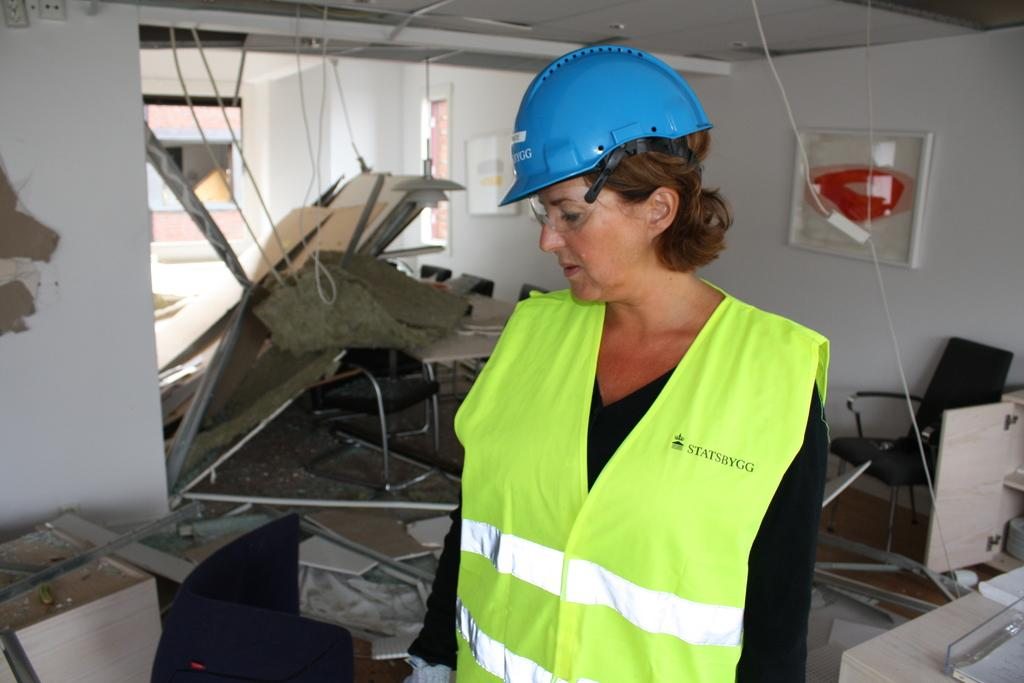Who is the main subject in the image? There is a lady in the center of the image. What is the lady wearing on her head? The lady is wearing a helmet. What can be seen in the background of the image? There are chairs and wooden materials in the background of the image. Where is the table located in the image? There is a table in the right corner of the image. Can you tell me how many pockets are on the lady's helmet in the image? There is no mention of pockets on the lady's helmet in the provided facts, so we cannot determine the number of pockets. Is there a giraffe visible in the image? No, there is no giraffe present in the image. 